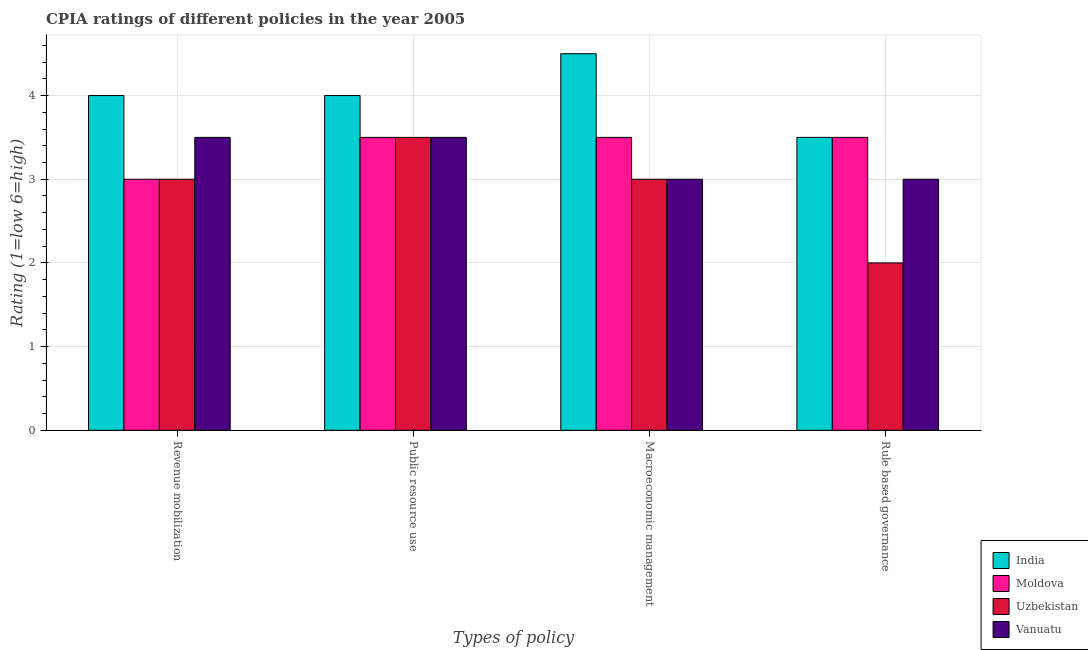Are the number of bars per tick equal to the number of legend labels?
Provide a short and direct response. Yes. How many bars are there on the 4th tick from the left?
Offer a very short reply. 4. How many bars are there on the 3rd tick from the right?
Your response must be concise. 4. What is the label of the 1st group of bars from the left?
Your response must be concise. Revenue mobilization. Across all countries, what is the minimum cpia rating of public resource use?
Your answer should be compact. 3.5. In which country was the cpia rating of macroeconomic management minimum?
Make the answer very short. Uzbekistan. What is the total cpia rating of rule based governance in the graph?
Provide a succinct answer. 12. What is the difference between the cpia rating of revenue mobilization in Moldova and that in Vanuatu?
Provide a succinct answer. -0.5. What is the average cpia rating of rule based governance per country?
Make the answer very short. 3. What is the ratio of the cpia rating of rule based governance in Uzbekistan to that in Vanuatu?
Offer a very short reply. 0.67. Is the cpia rating of rule based governance in Uzbekistan less than that in India?
Give a very brief answer. Yes. What is the difference between the highest and the second highest cpia rating of public resource use?
Make the answer very short. 0.5. What does the 2nd bar from the left in Macroeconomic management represents?
Offer a terse response. Moldova. What does the 4th bar from the right in Rule based governance represents?
Offer a terse response. India. Is it the case that in every country, the sum of the cpia rating of revenue mobilization and cpia rating of public resource use is greater than the cpia rating of macroeconomic management?
Offer a very short reply. Yes. What is the difference between two consecutive major ticks on the Y-axis?
Your response must be concise. 1. Does the graph contain grids?
Give a very brief answer. Yes. How are the legend labels stacked?
Offer a terse response. Vertical. What is the title of the graph?
Offer a very short reply. CPIA ratings of different policies in the year 2005. Does "Sri Lanka" appear as one of the legend labels in the graph?
Offer a very short reply. No. What is the label or title of the X-axis?
Your answer should be compact. Types of policy. What is the label or title of the Y-axis?
Offer a terse response. Rating (1=low 6=high). What is the Rating (1=low 6=high) of India in Revenue mobilization?
Provide a short and direct response. 4. What is the Rating (1=low 6=high) of Uzbekistan in Revenue mobilization?
Ensure brevity in your answer.  3. What is the Rating (1=low 6=high) of Vanuatu in Revenue mobilization?
Provide a succinct answer. 3.5. What is the Rating (1=low 6=high) of India in Public resource use?
Provide a succinct answer. 4. What is the Rating (1=low 6=high) in India in Macroeconomic management?
Provide a short and direct response. 4.5. What is the Rating (1=low 6=high) in Moldova in Macroeconomic management?
Your answer should be very brief. 3.5. What is the Rating (1=low 6=high) in India in Rule based governance?
Provide a short and direct response. 3.5. What is the Rating (1=low 6=high) in Uzbekistan in Rule based governance?
Make the answer very short. 2. What is the Rating (1=low 6=high) of Vanuatu in Rule based governance?
Your answer should be compact. 3. Across all Types of policy, what is the maximum Rating (1=low 6=high) of Vanuatu?
Provide a short and direct response. 3.5. Across all Types of policy, what is the minimum Rating (1=low 6=high) of Moldova?
Your answer should be compact. 3. Across all Types of policy, what is the minimum Rating (1=low 6=high) in Uzbekistan?
Provide a short and direct response. 2. What is the total Rating (1=low 6=high) in Moldova in the graph?
Your response must be concise. 13.5. What is the total Rating (1=low 6=high) in Uzbekistan in the graph?
Give a very brief answer. 11.5. What is the difference between the Rating (1=low 6=high) of India in Revenue mobilization and that in Public resource use?
Keep it short and to the point. 0. What is the difference between the Rating (1=low 6=high) of Moldova in Revenue mobilization and that in Public resource use?
Your answer should be compact. -0.5. What is the difference between the Rating (1=low 6=high) in Uzbekistan in Revenue mobilization and that in Public resource use?
Give a very brief answer. -0.5. What is the difference between the Rating (1=low 6=high) in Vanuatu in Revenue mobilization and that in Macroeconomic management?
Make the answer very short. 0.5. What is the difference between the Rating (1=low 6=high) of India in Revenue mobilization and that in Rule based governance?
Make the answer very short. 0.5. What is the difference between the Rating (1=low 6=high) of Vanuatu in Revenue mobilization and that in Rule based governance?
Give a very brief answer. 0.5. What is the difference between the Rating (1=low 6=high) of Moldova in Public resource use and that in Macroeconomic management?
Your answer should be very brief. 0. What is the difference between the Rating (1=low 6=high) of Vanuatu in Public resource use and that in Macroeconomic management?
Offer a terse response. 0.5. What is the difference between the Rating (1=low 6=high) of India in Public resource use and that in Rule based governance?
Offer a very short reply. 0.5. What is the difference between the Rating (1=low 6=high) of Vanuatu in Public resource use and that in Rule based governance?
Your answer should be very brief. 0.5. What is the difference between the Rating (1=low 6=high) in Uzbekistan in Macroeconomic management and that in Rule based governance?
Offer a very short reply. 1. What is the difference between the Rating (1=low 6=high) in Vanuatu in Macroeconomic management and that in Rule based governance?
Provide a short and direct response. 0. What is the difference between the Rating (1=low 6=high) of India in Revenue mobilization and the Rating (1=low 6=high) of Uzbekistan in Public resource use?
Make the answer very short. 0.5. What is the difference between the Rating (1=low 6=high) in India in Revenue mobilization and the Rating (1=low 6=high) in Vanuatu in Public resource use?
Your answer should be compact. 0.5. What is the difference between the Rating (1=low 6=high) in Moldova in Revenue mobilization and the Rating (1=low 6=high) in Uzbekistan in Public resource use?
Ensure brevity in your answer.  -0.5. What is the difference between the Rating (1=low 6=high) in Uzbekistan in Revenue mobilization and the Rating (1=low 6=high) in Vanuatu in Public resource use?
Your answer should be very brief. -0.5. What is the difference between the Rating (1=low 6=high) of India in Revenue mobilization and the Rating (1=low 6=high) of Uzbekistan in Macroeconomic management?
Offer a terse response. 1. What is the difference between the Rating (1=low 6=high) of Moldova in Revenue mobilization and the Rating (1=low 6=high) of Vanuatu in Macroeconomic management?
Your response must be concise. 0. What is the difference between the Rating (1=low 6=high) of Uzbekistan in Revenue mobilization and the Rating (1=low 6=high) of Vanuatu in Macroeconomic management?
Your answer should be very brief. 0. What is the difference between the Rating (1=low 6=high) of India in Revenue mobilization and the Rating (1=low 6=high) of Moldova in Rule based governance?
Provide a succinct answer. 0.5. What is the difference between the Rating (1=low 6=high) in Moldova in Revenue mobilization and the Rating (1=low 6=high) in Uzbekistan in Rule based governance?
Offer a terse response. 1. What is the difference between the Rating (1=low 6=high) of Uzbekistan in Revenue mobilization and the Rating (1=low 6=high) of Vanuatu in Rule based governance?
Make the answer very short. 0. What is the difference between the Rating (1=low 6=high) of Uzbekistan in Public resource use and the Rating (1=low 6=high) of Vanuatu in Macroeconomic management?
Keep it short and to the point. 0.5. What is the difference between the Rating (1=low 6=high) of India in Public resource use and the Rating (1=low 6=high) of Moldova in Rule based governance?
Provide a succinct answer. 0.5. What is the difference between the Rating (1=low 6=high) in Moldova in Public resource use and the Rating (1=low 6=high) in Uzbekistan in Rule based governance?
Make the answer very short. 1.5. What is the difference between the Rating (1=low 6=high) in Moldova in Public resource use and the Rating (1=low 6=high) in Vanuatu in Rule based governance?
Offer a very short reply. 0.5. What is the difference between the Rating (1=low 6=high) in Uzbekistan in Public resource use and the Rating (1=low 6=high) in Vanuatu in Rule based governance?
Provide a succinct answer. 0.5. What is the difference between the Rating (1=low 6=high) in India in Macroeconomic management and the Rating (1=low 6=high) in Uzbekistan in Rule based governance?
Keep it short and to the point. 2.5. What is the difference between the Rating (1=low 6=high) of India in Macroeconomic management and the Rating (1=low 6=high) of Vanuatu in Rule based governance?
Keep it short and to the point. 1.5. What is the difference between the Rating (1=low 6=high) in Moldova in Macroeconomic management and the Rating (1=low 6=high) in Uzbekistan in Rule based governance?
Keep it short and to the point. 1.5. What is the difference between the Rating (1=low 6=high) of Uzbekistan in Macroeconomic management and the Rating (1=low 6=high) of Vanuatu in Rule based governance?
Your answer should be very brief. 0. What is the average Rating (1=low 6=high) in India per Types of policy?
Give a very brief answer. 4. What is the average Rating (1=low 6=high) of Moldova per Types of policy?
Keep it short and to the point. 3.38. What is the average Rating (1=low 6=high) of Uzbekistan per Types of policy?
Ensure brevity in your answer.  2.88. What is the difference between the Rating (1=low 6=high) in India and Rating (1=low 6=high) in Moldova in Revenue mobilization?
Provide a short and direct response. 1. What is the difference between the Rating (1=low 6=high) of India and Rating (1=low 6=high) of Uzbekistan in Revenue mobilization?
Offer a very short reply. 1. What is the difference between the Rating (1=low 6=high) of India and Rating (1=low 6=high) of Vanuatu in Revenue mobilization?
Your answer should be very brief. 0.5. What is the difference between the Rating (1=low 6=high) in Moldova and Rating (1=low 6=high) in Vanuatu in Revenue mobilization?
Ensure brevity in your answer.  -0.5. What is the difference between the Rating (1=low 6=high) in Uzbekistan and Rating (1=low 6=high) in Vanuatu in Revenue mobilization?
Your answer should be compact. -0.5. What is the difference between the Rating (1=low 6=high) in India and Rating (1=low 6=high) in Moldova in Public resource use?
Make the answer very short. 0.5. What is the difference between the Rating (1=low 6=high) in India and Rating (1=low 6=high) in Uzbekistan in Public resource use?
Keep it short and to the point. 0.5. What is the difference between the Rating (1=low 6=high) in India and Rating (1=low 6=high) in Vanuatu in Public resource use?
Provide a succinct answer. 0.5. What is the difference between the Rating (1=low 6=high) of India and Rating (1=low 6=high) of Uzbekistan in Macroeconomic management?
Provide a short and direct response. 1.5. What is the difference between the Rating (1=low 6=high) in India and Rating (1=low 6=high) in Vanuatu in Macroeconomic management?
Offer a very short reply. 1.5. What is the difference between the Rating (1=low 6=high) of Moldova and Rating (1=low 6=high) of Uzbekistan in Macroeconomic management?
Make the answer very short. 0.5. What is the difference between the Rating (1=low 6=high) of Moldova and Rating (1=low 6=high) of Vanuatu in Macroeconomic management?
Ensure brevity in your answer.  0.5. What is the difference between the Rating (1=low 6=high) in India and Rating (1=low 6=high) in Vanuatu in Rule based governance?
Your response must be concise. 0.5. What is the difference between the Rating (1=low 6=high) of Moldova and Rating (1=low 6=high) of Uzbekistan in Rule based governance?
Provide a succinct answer. 1.5. What is the difference between the Rating (1=low 6=high) in Moldova and Rating (1=low 6=high) in Vanuatu in Rule based governance?
Ensure brevity in your answer.  0.5. What is the difference between the Rating (1=low 6=high) of Uzbekistan and Rating (1=low 6=high) of Vanuatu in Rule based governance?
Offer a very short reply. -1. What is the ratio of the Rating (1=low 6=high) in India in Revenue mobilization to that in Public resource use?
Give a very brief answer. 1. What is the ratio of the Rating (1=low 6=high) of Vanuatu in Revenue mobilization to that in Public resource use?
Give a very brief answer. 1. What is the ratio of the Rating (1=low 6=high) in Uzbekistan in Revenue mobilization to that in Rule based governance?
Keep it short and to the point. 1.5. What is the ratio of the Rating (1=low 6=high) of India in Public resource use to that in Macroeconomic management?
Ensure brevity in your answer.  0.89. What is the ratio of the Rating (1=low 6=high) of Moldova in Public resource use to that in Macroeconomic management?
Your response must be concise. 1. What is the ratio of the Rating (1=low 6=high) of Uzbekistan in Public resource use to that in Macroeconomic management?
Make the answer very short. 1.17. What is the ratio of the Rating (1=low 6=high) in Vanuatu in Public resource use to that in Macroeconomic management?
Make the answer very short. 1.17. What is the ratio of the Rating (1=low 6=high) in Uzbekistan in Public resource use to that in Rule based governance?
Provide a short and direct response. 1.75. What is the ratio of the Rating (1=low 6=high) of Vanuatu in Public resource use to that in Rule based governance?
Give a very brief answer. 1.17. What is the ratio of the Rating (1=low 6=high) of India in Macroeconomic management to that in Rule based governance?
Provide a short and direct response. 1.29. What is the ratio of the Rating (1=low 6=high) of Moldova in Macroeconomic management to that in Rule based governance?
Make the answer very short. 1. What is the difference between the highest and the second highest Rating (1=low 6=high) in India?
Make the answer very short. 0.5. What is the difference between the highest and the second highest Rating (1=low 6=high) of Moldova?
Your response must be concise. 0. What is the difference between the highest and the lowest Rating (1=low 6=high) in Uzbekistan?
Make the answer very short. 1.5. 